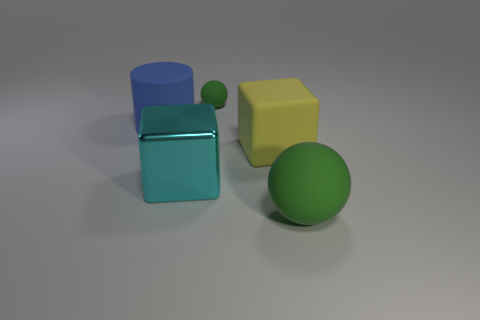Subtract all blocks. How many objects are left? 3 Add 4 blue objects. How many objects exist? 9 Subtract all big gray cubes. Subtract all yellow blocks. How many objects are left? 4 Add 3 metal blocks. How many metal blocks are left? 4 Add 3 green balls. How many green balls exist? 5 Subtract 0 yellow balls. How many objects are left? 5 